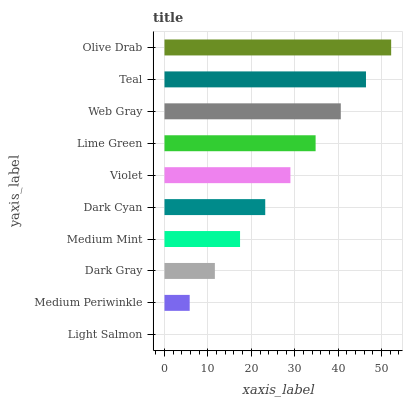Is Light Salmon the minimum?
Answer yes or no. Yes. Is Olive Drab the maximum?
Answer yes or no. Yes. Is Medium Periwinkle the minimum?
Answer yes or no. No. Is Medium Periwinkle the maximum?
Answer yes or no. No. Is Medium Periwinkle greater than Light Salmon?
Answer yes or no. Yes. Is Light Salmon less than Medium Periwinkle?
Answer yes or no. Yes. Is Light Salmon greater than Medium Periwinkle?
Answer yes or no. No. Is Medium Periwinkle less than Light Salmon?
Answer yes or no. No. Is Violet the high median?
Answer yes or no. Yes. Is Dark Cyan the low median?
Answer yes or no. Yes. Is Teal the high median?
Answer yes or no. No. Is Olive Drab the low median?
Answer yes or no. No. 